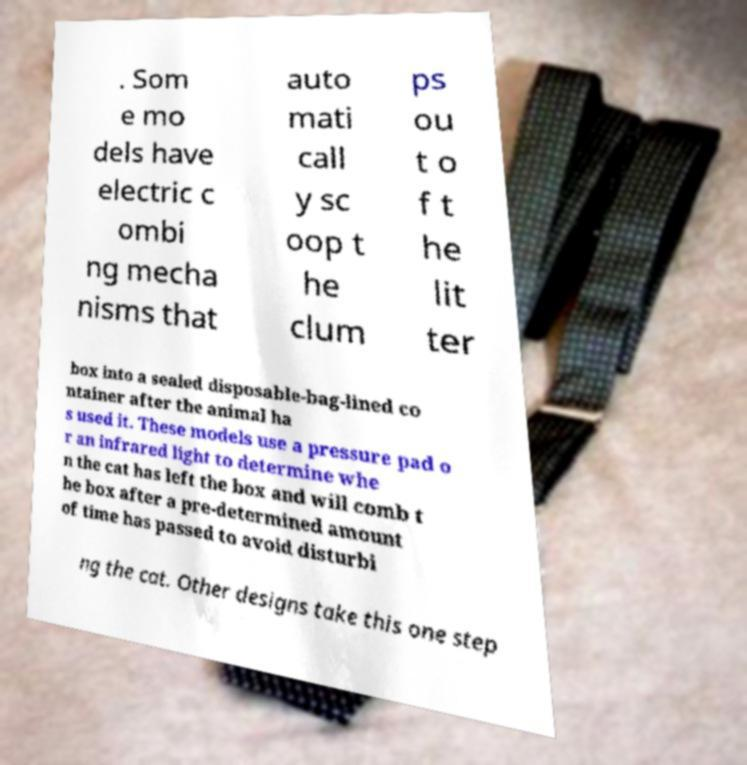Please identify and transcribe the text found in this image. . Som e mo dels have electric c ombi ng mecha nisms that auto mati call y sc oop t he clum ps ou t o f t he lit ter box into a sealed disposable-bag-lined co ntainer after the animal ha s used it. These models use a pressure pad o r an infrared light to determine whe n the cat has left the box and will comb t he box after a pre-determined amount of time has passed to avoid disturbi ng the cat. Other designs take this one step 